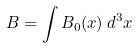Convert formula to latex. <formula><loc_0><loc_0><loc_500><loc_500>B = \int B _ { 0 } ( x ) \, d ^ { 3 } x</formula> 